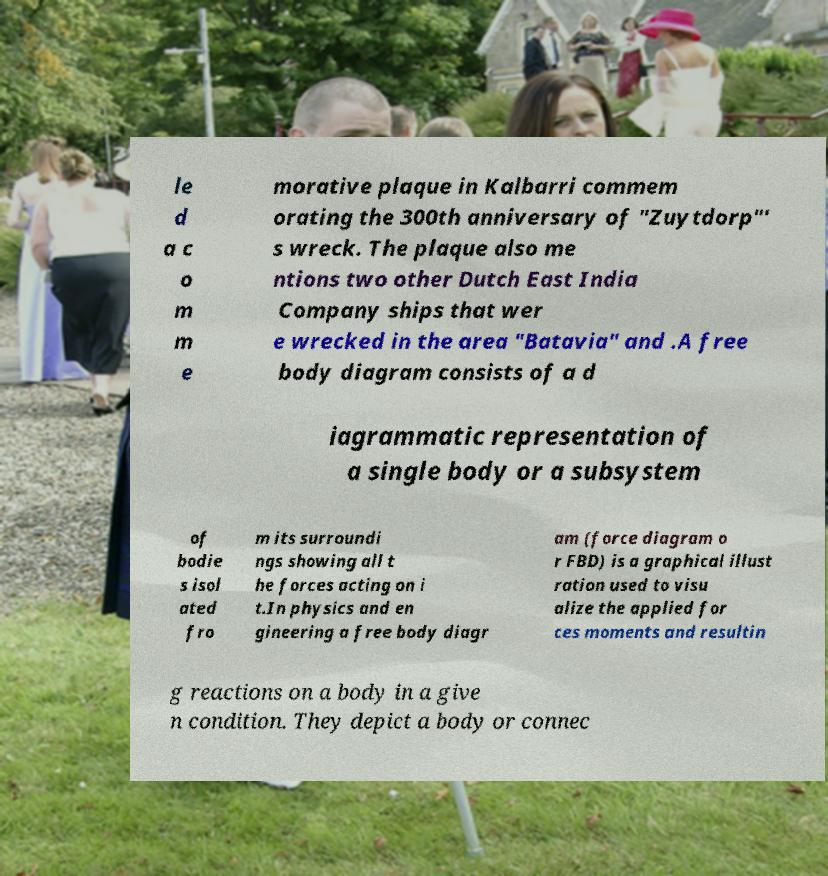Please identify and transcribe the text found in this image. le d a c o m m e morative plaque in Kalbarri commem orating the 300th anniversary of "Zuytdorp"' s wreck. The plaque also me ntions two other Dutch East India Company ships that wer e wrecked in the area "Batavia" and .A free body diagram consists of a d iagrammatic representation of a single body or a subsystem of bodie s isol ated fro m its surroundi ngs showing all t he forces acting on i t.In physics and en gineering a free body diagr am (force diagram o r FBD) is a graphical illust ration used to visu alize the applied for ces moments and resultin g reactions on a body in a give n condition. They depict a body or connec 